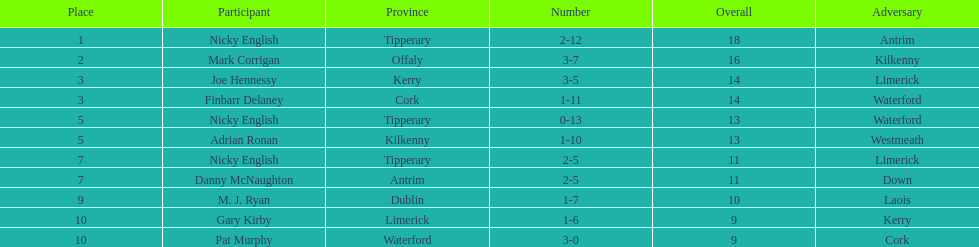Who was the top ranked player in a single game? Nicky English. 